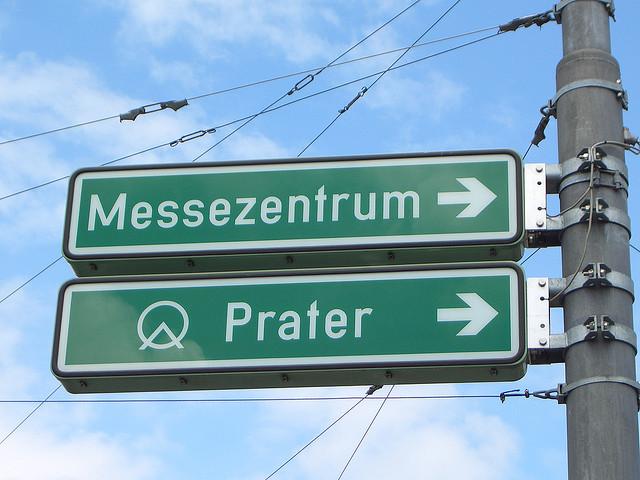What does the lower sign say?
Be succinct. Prayer. Are these Austrian street signs?
Write a very short answer. Yes. What is the 9th letter of the word on the top sign?
Answer briefly. T. What are the wires in the sky?
Be succinct. Yes. 